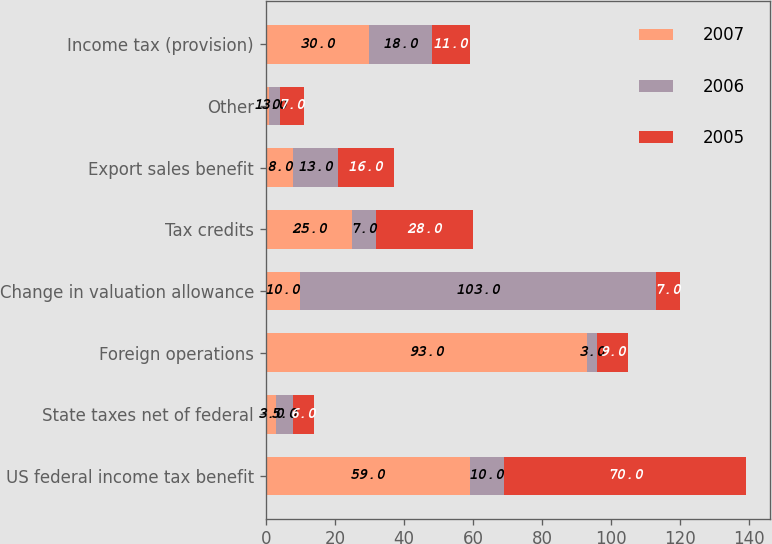<chart> <loc_0><loc_0><loc_500><loc_500><stacked_bar_chart><ecel><fcel>US federal income tax benefit<fcel>State taxes net of federal<fcel>Foreign operations<fcel>Change in valuation allowance<fcel>Tax credits<fcel>Export sales benefit<fcel>Other<fcel>Income tax (provision)<nl><fcel>2007<fcel>59<fcel>3<fcel>93<fcel>10<fcel>25<fcel>8<fcel>1<fcel>30<nl><fcel>2006<fcel>10<fcel>5<fcel>3<fcel>103<fcel>7<fcel>13<fcel>3<fcel>18<nl><fcel>2005<fcel>70<fcel>6<fcel>9<fcel>7<fcel>28<fcel>16<fcel>7<fcel>11<nl></chart> 